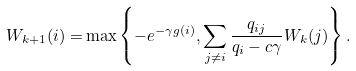<formula> <loc_0><loc_0><loc_500><loc_500>W _ { k + 1 } ( i ) = & \max \left \{ - e ^ { - \gamma g ( i ) } , \sum _ { j \neq i } \frac { q _ { i j } } { q _ { i } - c \gamma } W _ { k } ( j ) \right \} .</formula> 